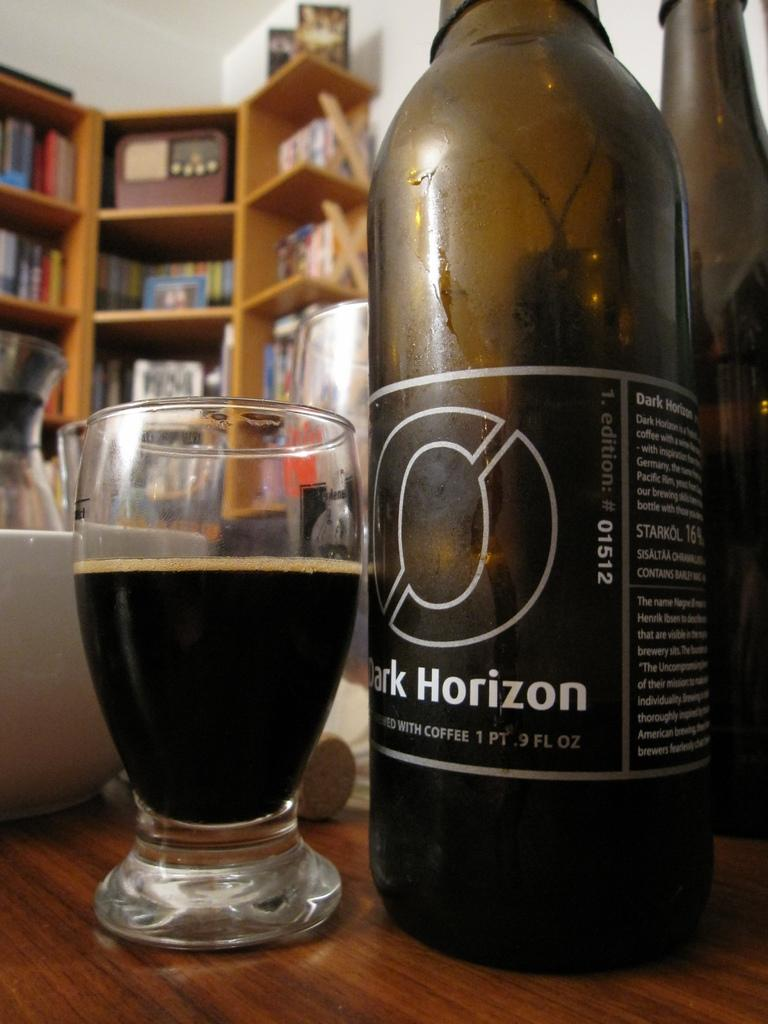Provide a one-sentence caption for the provided image. A glass next to a bottle of Dark Horizon. 